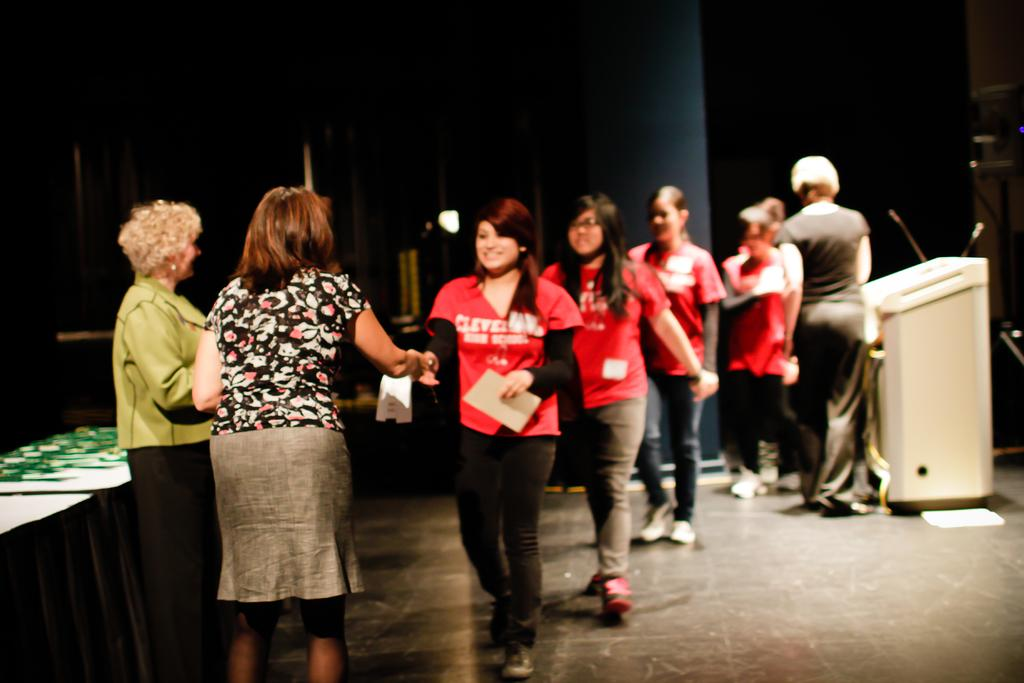Who can be seen on the left side of the image? There are two men standing on the left side of the image. What are the girls doing on the right side of the image? The girls are walking on the right side of the image. What color t-shirts are the girls wearing? The girls are wearing red color t-shirts. What is the woman near in the image? There is a woman standing near a podium in the image. Can you see an owl sitting on the woman's shoulder in the image? No, there is no owl present in the image. What type of dress is the woman wearing near the podium? The provided facts do not mention the woman's dress, so we cannot answer this question. 